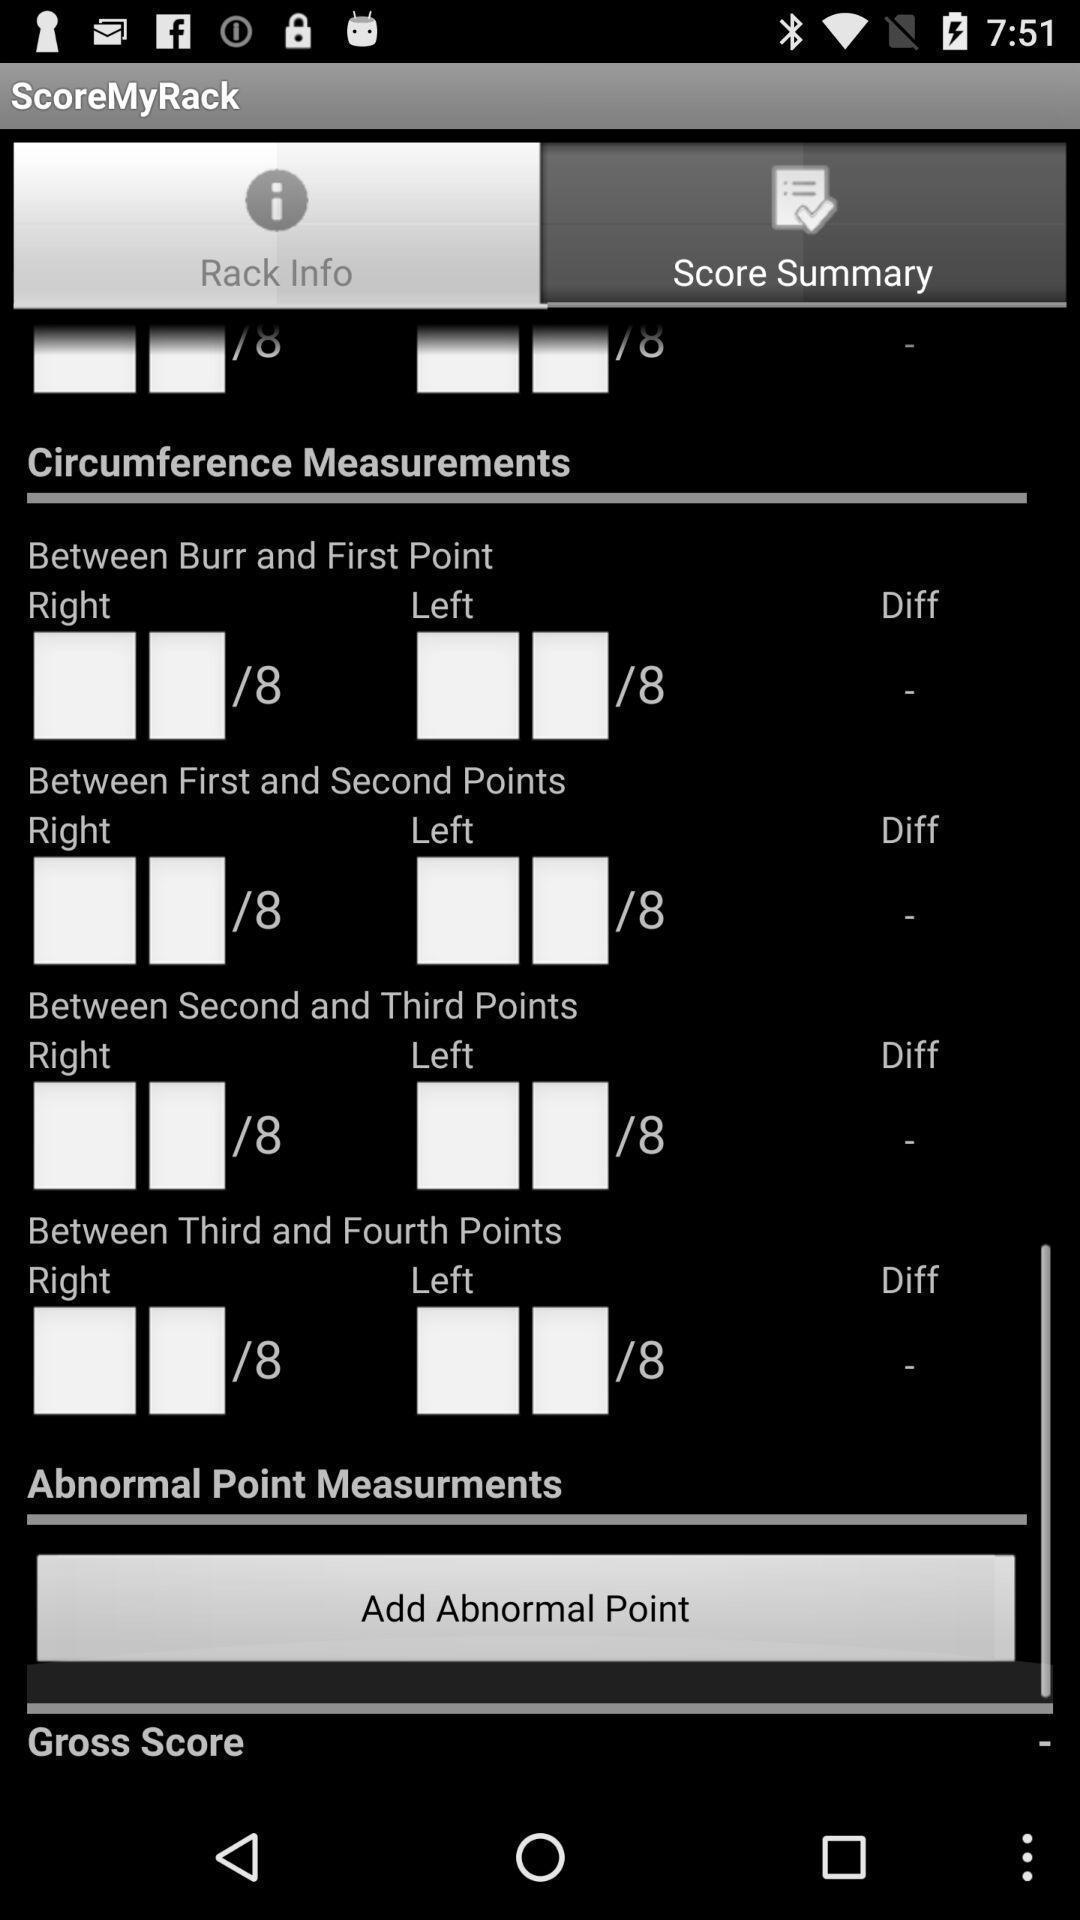What details can you identify in this image? Page showing the background info. 